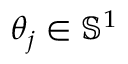<formula> <loc_0><loc_0><loc_500><loc_500>\theta _ { j } \in \mathbb { S } ^ { 1 }</formula> 